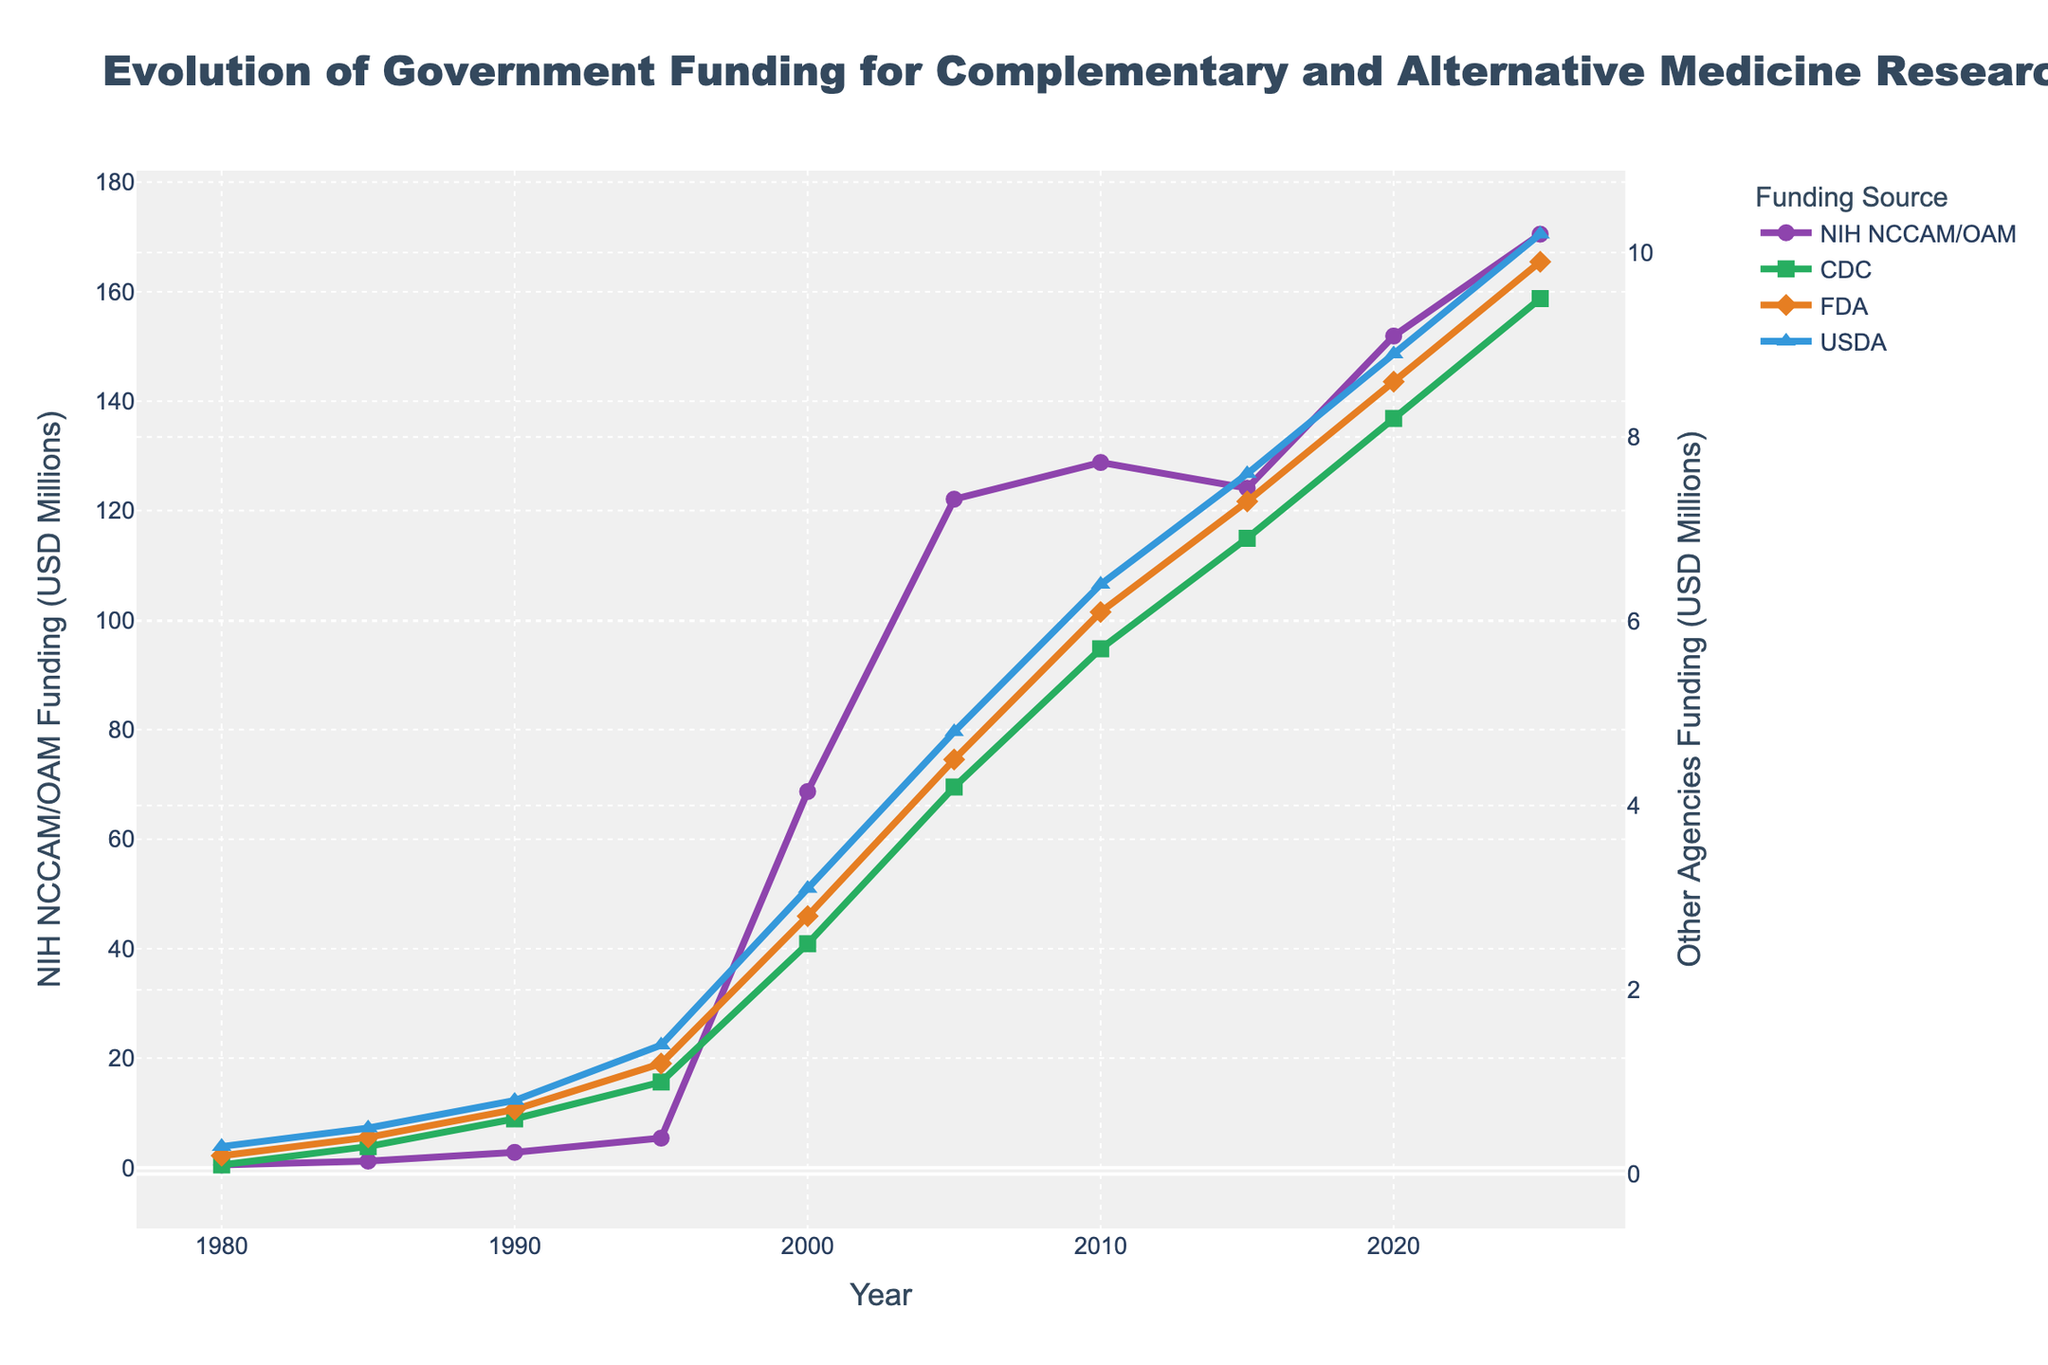What is the overall trend of NIH NCCAM/OAM funding from 1980 to 2025? The NIH NCCAM/OAM funding shows a consistent increase over time. Beginning at 0.5 million in 1980, it rises to 170.5 million by 2025, indicating a significant upward trend.
Answer: Increasing Which agency has the steepest increase in funding from 2000 to 2025? By comparing the steepness of the lines between 2000 and 2025, NIH NCCAM/OAM shows a sharp rise from 68.7 million to 170.5 million, more than doubling. Other agencies also increase but not as sharply.
Answer: NIH NCCAM/OAM What was the CDC's funding for CAM research in 2010, and how does it compare to FDA funding in the same year? CDC's funding for CAM research in 2010 was 5.7 million. The FDA funding for botanical research in the same year was 6.1 million. By comparing the two, CDC's funding is slightly less.
Answer: CDC: 5.7 million, FDA: 6.1 million How does the USDA funding in 2020 compare to its funding in 1980? In 2020, USDA funding for herbal medicine research was 8.9 million. In 1980, it was 0.3 million. By calculating the difference, 8.9 - 0.3 = 8.6 million shows an increase of 8.6 million over the 40 years.
Answer: Increased by 8.6 million What is the ratio of NIH NCCAM/OAM funding to CDC funding for CAM research in 2000? NIH funding in 2000 was 68.7 million, and CDC funding was 2.5 million. The ratio is calculated as 68.7 / 2.5 = 27.48.
Answer: 27.48 In which year did the FDA funding for botanical research first surpass 1 million USD? By examining the trends, FDA funding surpassed 1 million USD in 1995, where it reached 1.2 million USD.
Answer: 1995 Between 1980 and 2025, which agency had the smallest increase in funding? By comparing the funding increases over the years for all agencies, the CDC funding goes from 0.1 million in 1980 to 9.5 million in 2025, which is a smaller increase compared to others like NIH.
Answer: CDC How much more funding did the NIH NCCAM/OAM receive compared to the USDA in 2025? In 2025, NIH received 170.5 million whereas USDA received 10.2 million. The difference is calculated as 170.5 - 10.2 = 160.3 million.
Answer: 160.3 million What is the average annual increase in USDA funding from 2000 to 2025? USDA funding was 3.1 million in 2000 and 10.2 million in 2025. The increase over 25 years is 10.2 - 3.1 = 7.1 million. The average annual increase is 7.1 / 25 = 0.284 million per year.
Answer: 0.284 million per year What is the difference in funding between the NIH NCCAM/OAM and the CDC in 1985? NIH NCCAM/OAM funding in 1985 was 1.2 million, and CDC funding was 0.3 million. The difference is 1.2 - 0.3 = 0.9 million.
Answer: 0.9 million 